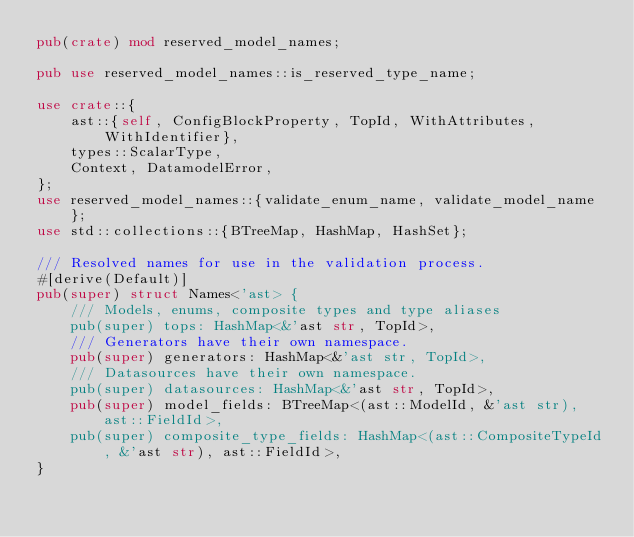<code> <loc_0><loc_0><loc_500><loc_500><_Rust_>pub(crate) mod reserved_model_names;

pub use reserved_model_names::is_reserved_type_name;

use crate::{
    ast::{self, ConfigBlockProperty, TopId, WithAttributes, WithIdentifier},
    types::ScalarType,
    Context, DatamodelError,
};
use reserved_model_names::{validate_enum_name, validate_model_name};
use std::collections::{BTreeMap, HashMap, HashSet};

/// Resolved names for use in the validation process.
#[derive(Default)]
pub(super) struct Names<'ast> {
    /// Models, enums, composite types and type aliases
    pub(super) tops: HashMap<&'ast str, TopId>,
    /// Generators have their own namespace.
    pub(super) generators: HashMap<&'ast str, TopId>,
    /// Datasources have their own namespace.
    pub(super) datasources: HashMap<&'ast str, TopId>,
    pub(super) model_fields: BTreeMap<(ast::ModelId, &'ast str), ast::FieldId>,
    pub(super) composite_type_fields: HashMap<(ast::CompositeTypeId, &'ast str), ast::FieldId>,
}
</code> 